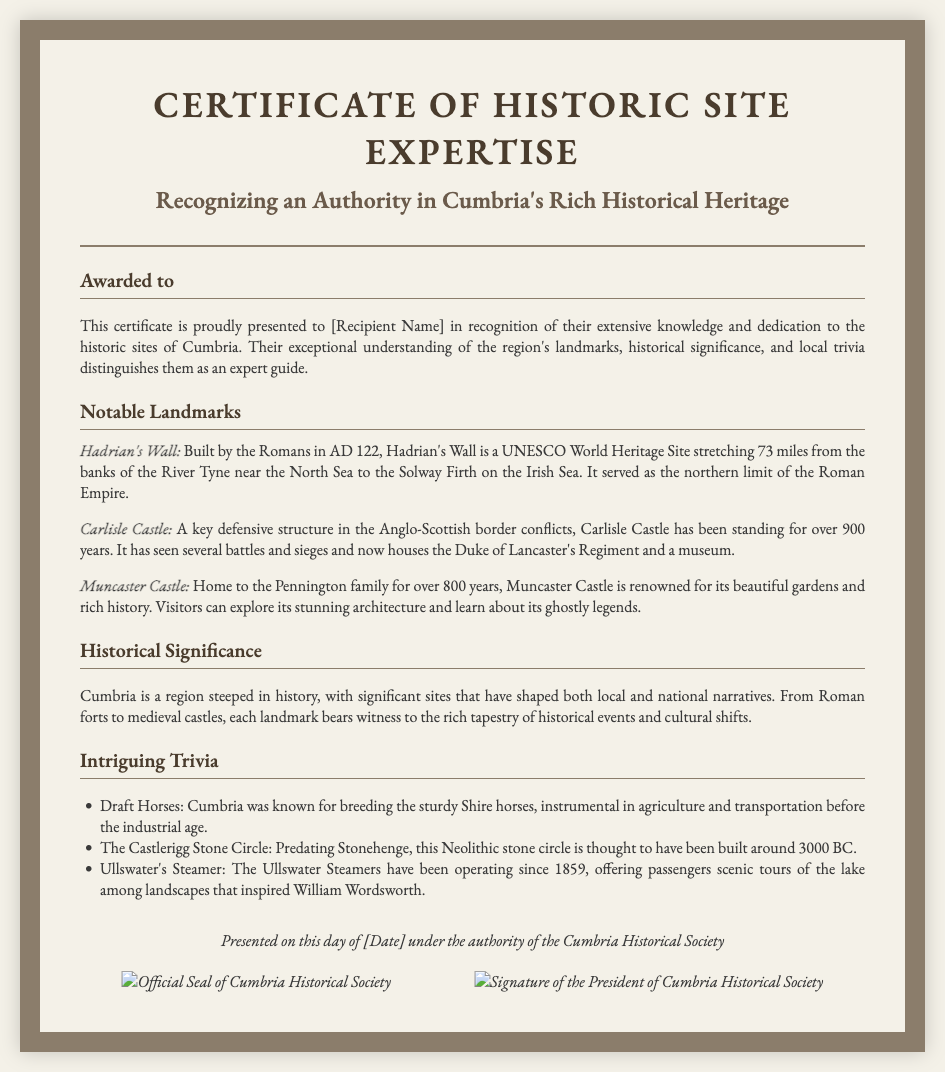What is the title of the certificate? The title of the certificate is prominently displayed at the top of the document.
Answer: Certificate of Historic Site Expertise Who is the certificate awarded to? The document specifies the recipient's role in recognition of their expertise.
Answer: [Recipient Name] What is a notable landmark mentioned in the document? The certificate lists specific landmarks as part of its content.
Answer: Hadrian's Wall What significant historical structure is over 900 years old? The document highlights a specific landmark's historical age and significance.
Answer: Carlisle Castle What year was Hadrian's Wall built? The construction year of Hadrian's Wall is detailed in the description.
Answer: AD 122 Which historical society presented the certificate? The footer indicates the authority that issued the certificate.
Answer: Cumbria Historical Society What is one intriguing trivia fact mentioned? The document includes a list of trivia related to Cumbria's history.
Answer: Draft Horses How is the document styled? The description indicates the design aspects of the certificate.
Answer: Vintage imagery and official seals When was the certificate presented? The footer contains a placeholder for the issuance date of the certificate.
Answer: [Date] 